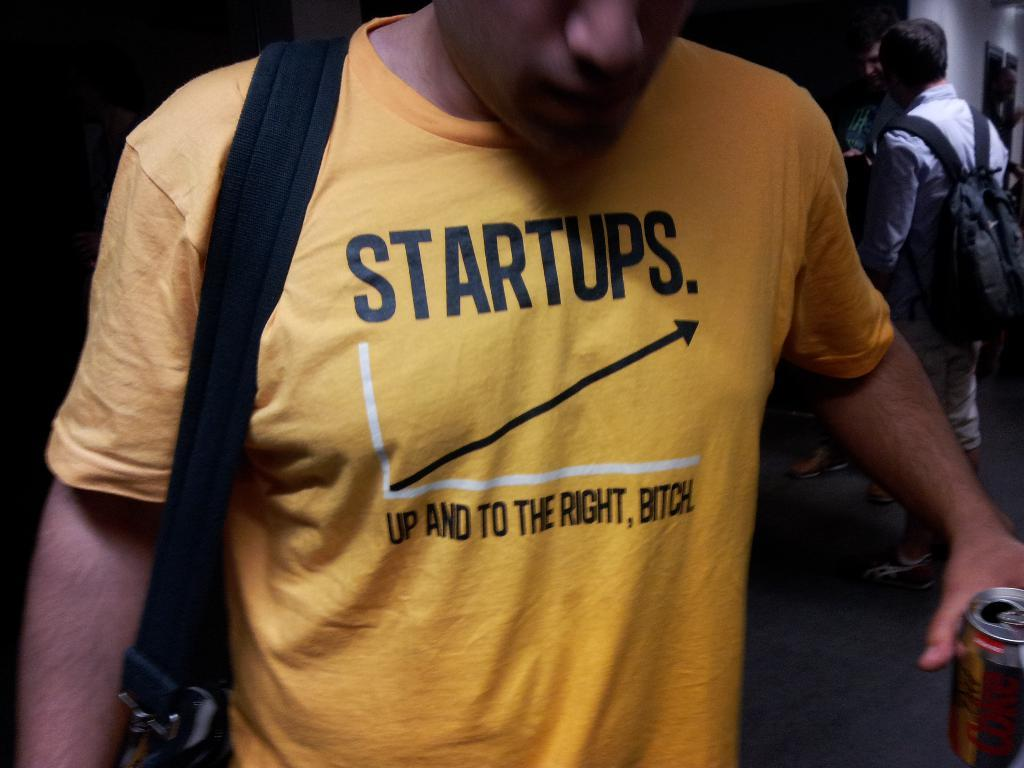<image>
Give a short and clear explanation of the subsequent image. A man wears a yellow t-shirt with an offensive slogan on it. 